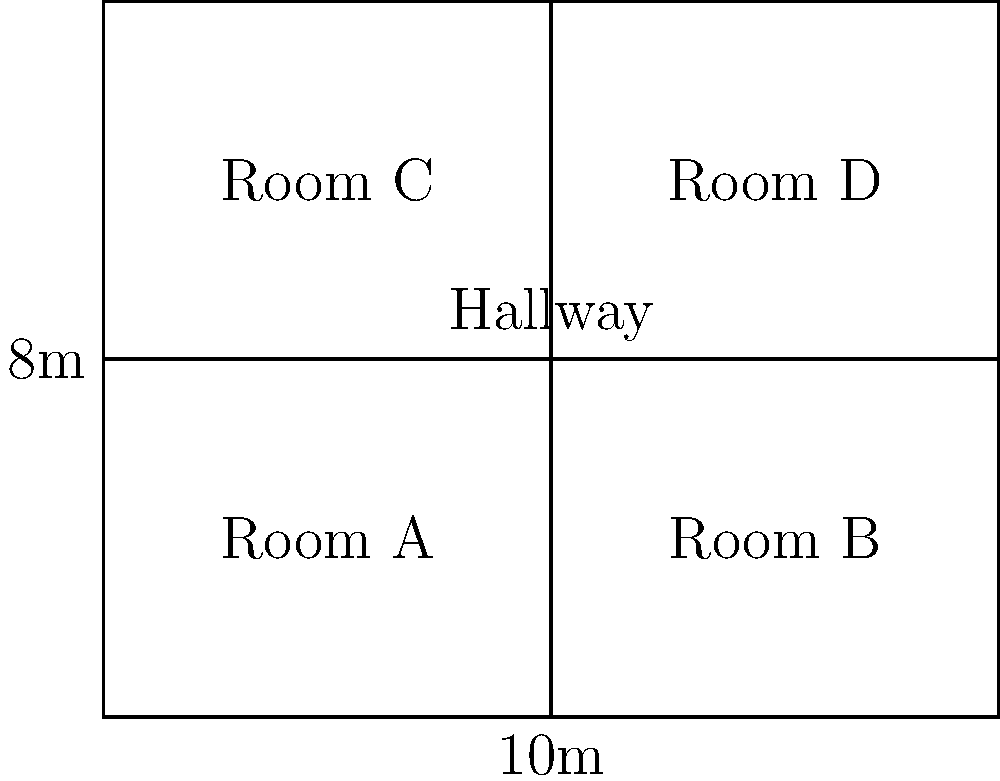Given the floor plan diagram of a hospital wing, which shows four patient rooms (A, B, C, and D) separated by a central hallway, calculate the optimal layout that maximizes the total patient room area while maintaining a minimum hallway width of 2 meters. What is the maximum total patient room area in square meters? To solve this problem, we'll follow these steps:

1. Analyze the given information:
   - Total floor dimensions: 10m x 8m
   - Current layout: 4 equal-sized rooms
   - Hallway running horizontally through the center

2. Calculate the current room dimensions:
   - Each room is 5m x 4m = 20 m²
   - Total current patient room area: 4 * 20 m² = 80 m²

3. Optimize the layout:
   - The hallway must be at least 2m wide
   - We can move the hallway to maximize room area

4. Calculate the new layout:
   - Total height: 8m
   - Hallway width: 2m
   - Remaining height for rooms: 8m - 2m = 6m

5. Calculate the new room dimensions:
   - Width remains 5m
   - New height: 6m
   - New room area: 5m * 6m = 30 m²

6. Calculate the total optimized patient room area:
   - Number of rooms: 4
   - Total area: 4 * 30 m² = 120 m²

Therefore, the optimal layout involves moving the hallway to create two rows of larger rooms, each measuring 5m x 6m, with a 2m wide hallway between them.
Answer: 120 m² 